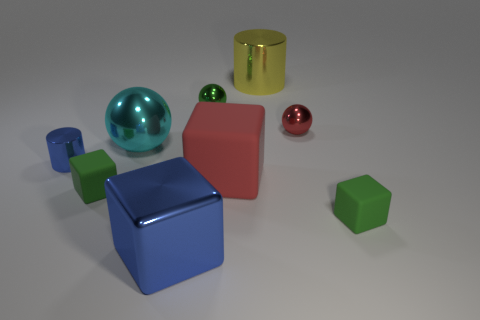Is the number of cubes that are on the left side of the big blue metal block greater than the number of purple metal spheres?
Offer a very short reply. Yes. How many yellow cylinders are in front of the large red block?
Your answer should be compact. 0. Is there a yellow metal cylinder that has the same size as the red ball?
Your response must be concise. No. There is another large thing that is the same shape as the big red thing; what is its color?
Offer a terse response. Blue. There is a blue thing left of the blue cube; does it have the same size as the green matte cube right of the cyan shiny sphere?
Give a very brief answer. Yes. Is there a small brown metallic thing of the same shape as the tiny green metal object?
Keep it short and to the point. No. Are there an equal number of large cyan shiny objects that are behind the large cyan metallic thing and blue objects?
Your response must be concise. No. Is the size of the green metal thing the same as the green block to the left of the small red object?
Keep it short and to the point. Yes. What number of big brown cylinders are the same material as the blue cylinder?
Provide a succinct answer. 0. Do the green metallic object and the red matte cube have the same size?
Give a very brief answer. No. 